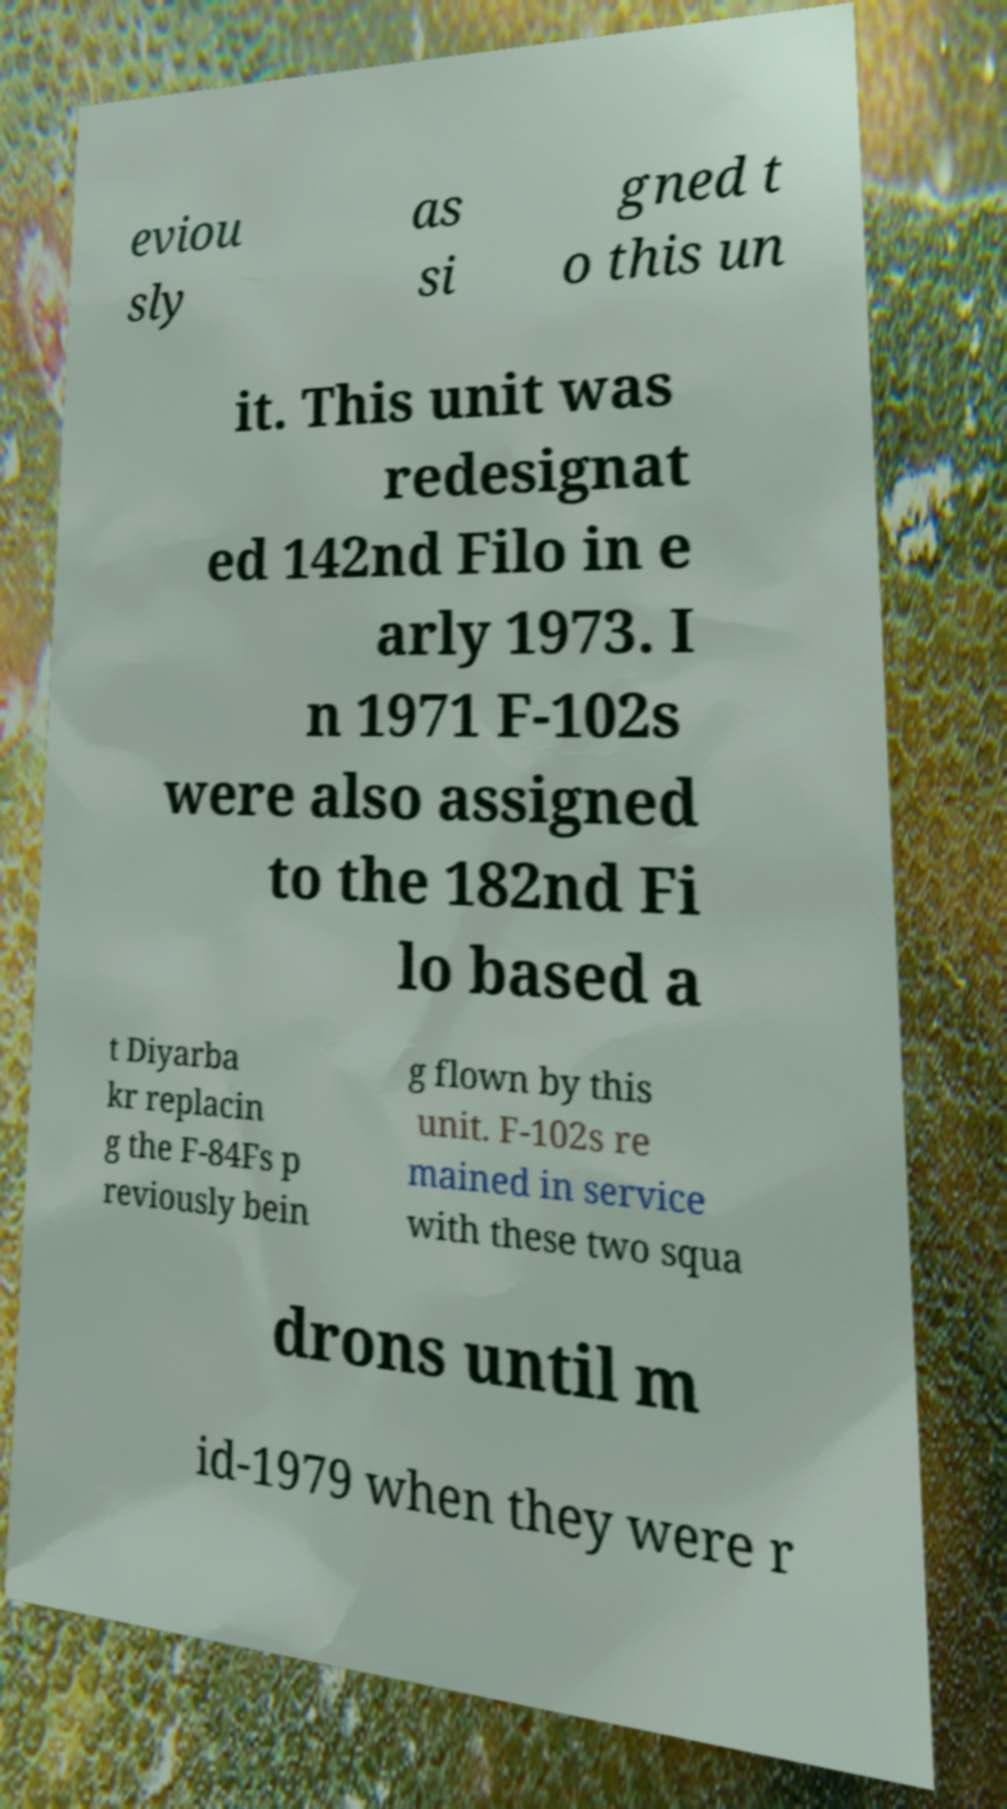Could you assist in decoding the text presented in this image and type it out clearly? eviou sly as si gned t o this un it. This unit was redesignat ed 142nd Filo in e arly 1973. I n 1971 F-102s were also assigned to the 182nd Fi lo based a t Diyarba kr replacin g the F-84Fs p reviously bein g flown by this unit. F-102s re mained in service with these two squa drons until m id-1979 when they were r 